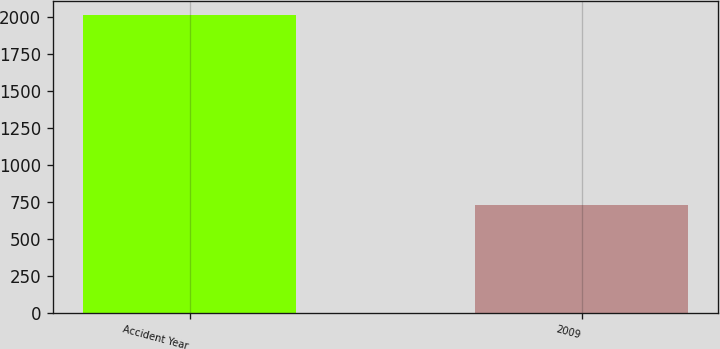Convert chart. <chart><loc_0><loc_0><loc_500><loc_500><bar_chart><fcel>Accident Year<fcel>2009<nl><fcel>2010<fcel>727<nl></chart> 